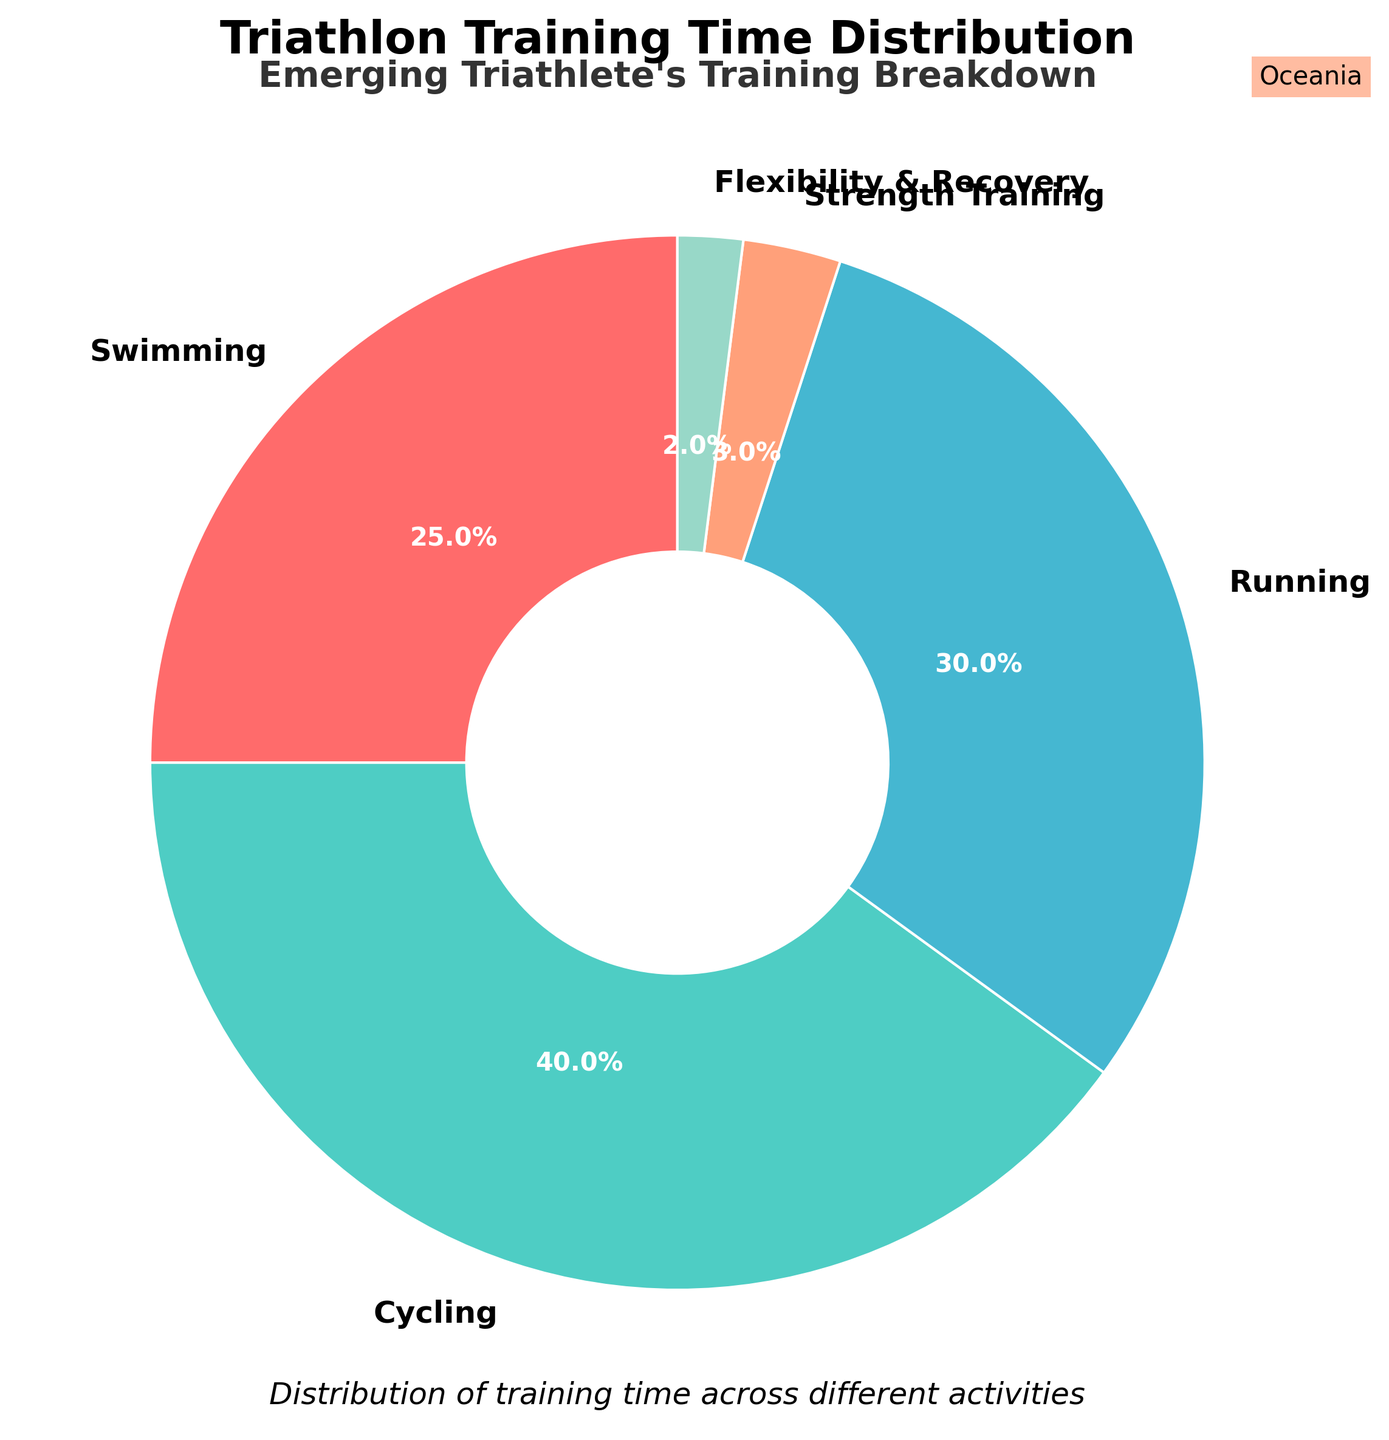What's the total percentage of training time spent on swimming and cycling? To find the total percentage of training time spent on swimming and cycling, sum the percentages for these activities. Swimming is 25% and cycling is 40%, so 25 + 40 = 65.
Answer: 65% Which activity takes the least amount of training time? The activities and their percentages are shown in the figure. Flexibility & Recovery has the smallest slice of the pie chart with 2%.
Answer: Flexibility & Recovery Is the percentage of time spent on running greater than the percentage of time spent on swimming? The figure shows percentages: running is 30% and swimming is 25%. Since 30% is more than 25%, the answer is yes.
Answer: Yes What's the difference in training time between cycling and running? Cycling occupies 40% and running occupies 30% of the training time. Subtract running from cycling: 40 - 30 = 10.
Answer: 10% Combine the time spent on strength training and flexibility and recovery. How does their combined percentage compare to swimming? Strength Training is 3% and Flexibility & Recovery is 2%. Their combined percentage is 3 + 2 = 5%. Swimming is 25%, which is 25 - 5 = 20% more than their combined percentage.
Answer: 20% more What percentage of training time is dedicated to activities other than cycling? To find the percentage of activities other than cycling, deduct cycling's percentage from 100%. Cycling is 40%, so 100 - 40 = 60.
Answer: 60% Is more time dedicated to running or to non-cardio activities (strength training and flexibility & recovery)? Running is 30%, and non-cardio activities (strength training and flexibility & recovery) are 3% + 2% = 5%. Since 30% > 5%, more time is dedicated to running.
Answer: Running Which is the most dominant color in the pie chart? The largest segment, which represents the dominant activity (cycling), is colored in green. Thus, green is the most dominant color in the pie chart.
Answer: Green If you increase the strength training time by 2% and decrease swimming by 2%, what is the new percentage of training time for these activities? Original percentages are strength training: 3% and swimming: 25%. After adjustments, strength training becomes 3 + 2 = 5% and swimming becomes 25 - 2 = 23%.
Answer: Strength training 5%, Swimming 23% What is the combined training time percentage for activities other than swimming and cycling? Sum the percentages of other categories: Running (30%), Strength Training (3%), and Flexibility & Recovery (2%). 30 + 3 + 2 = 35.
Answer: 35% 